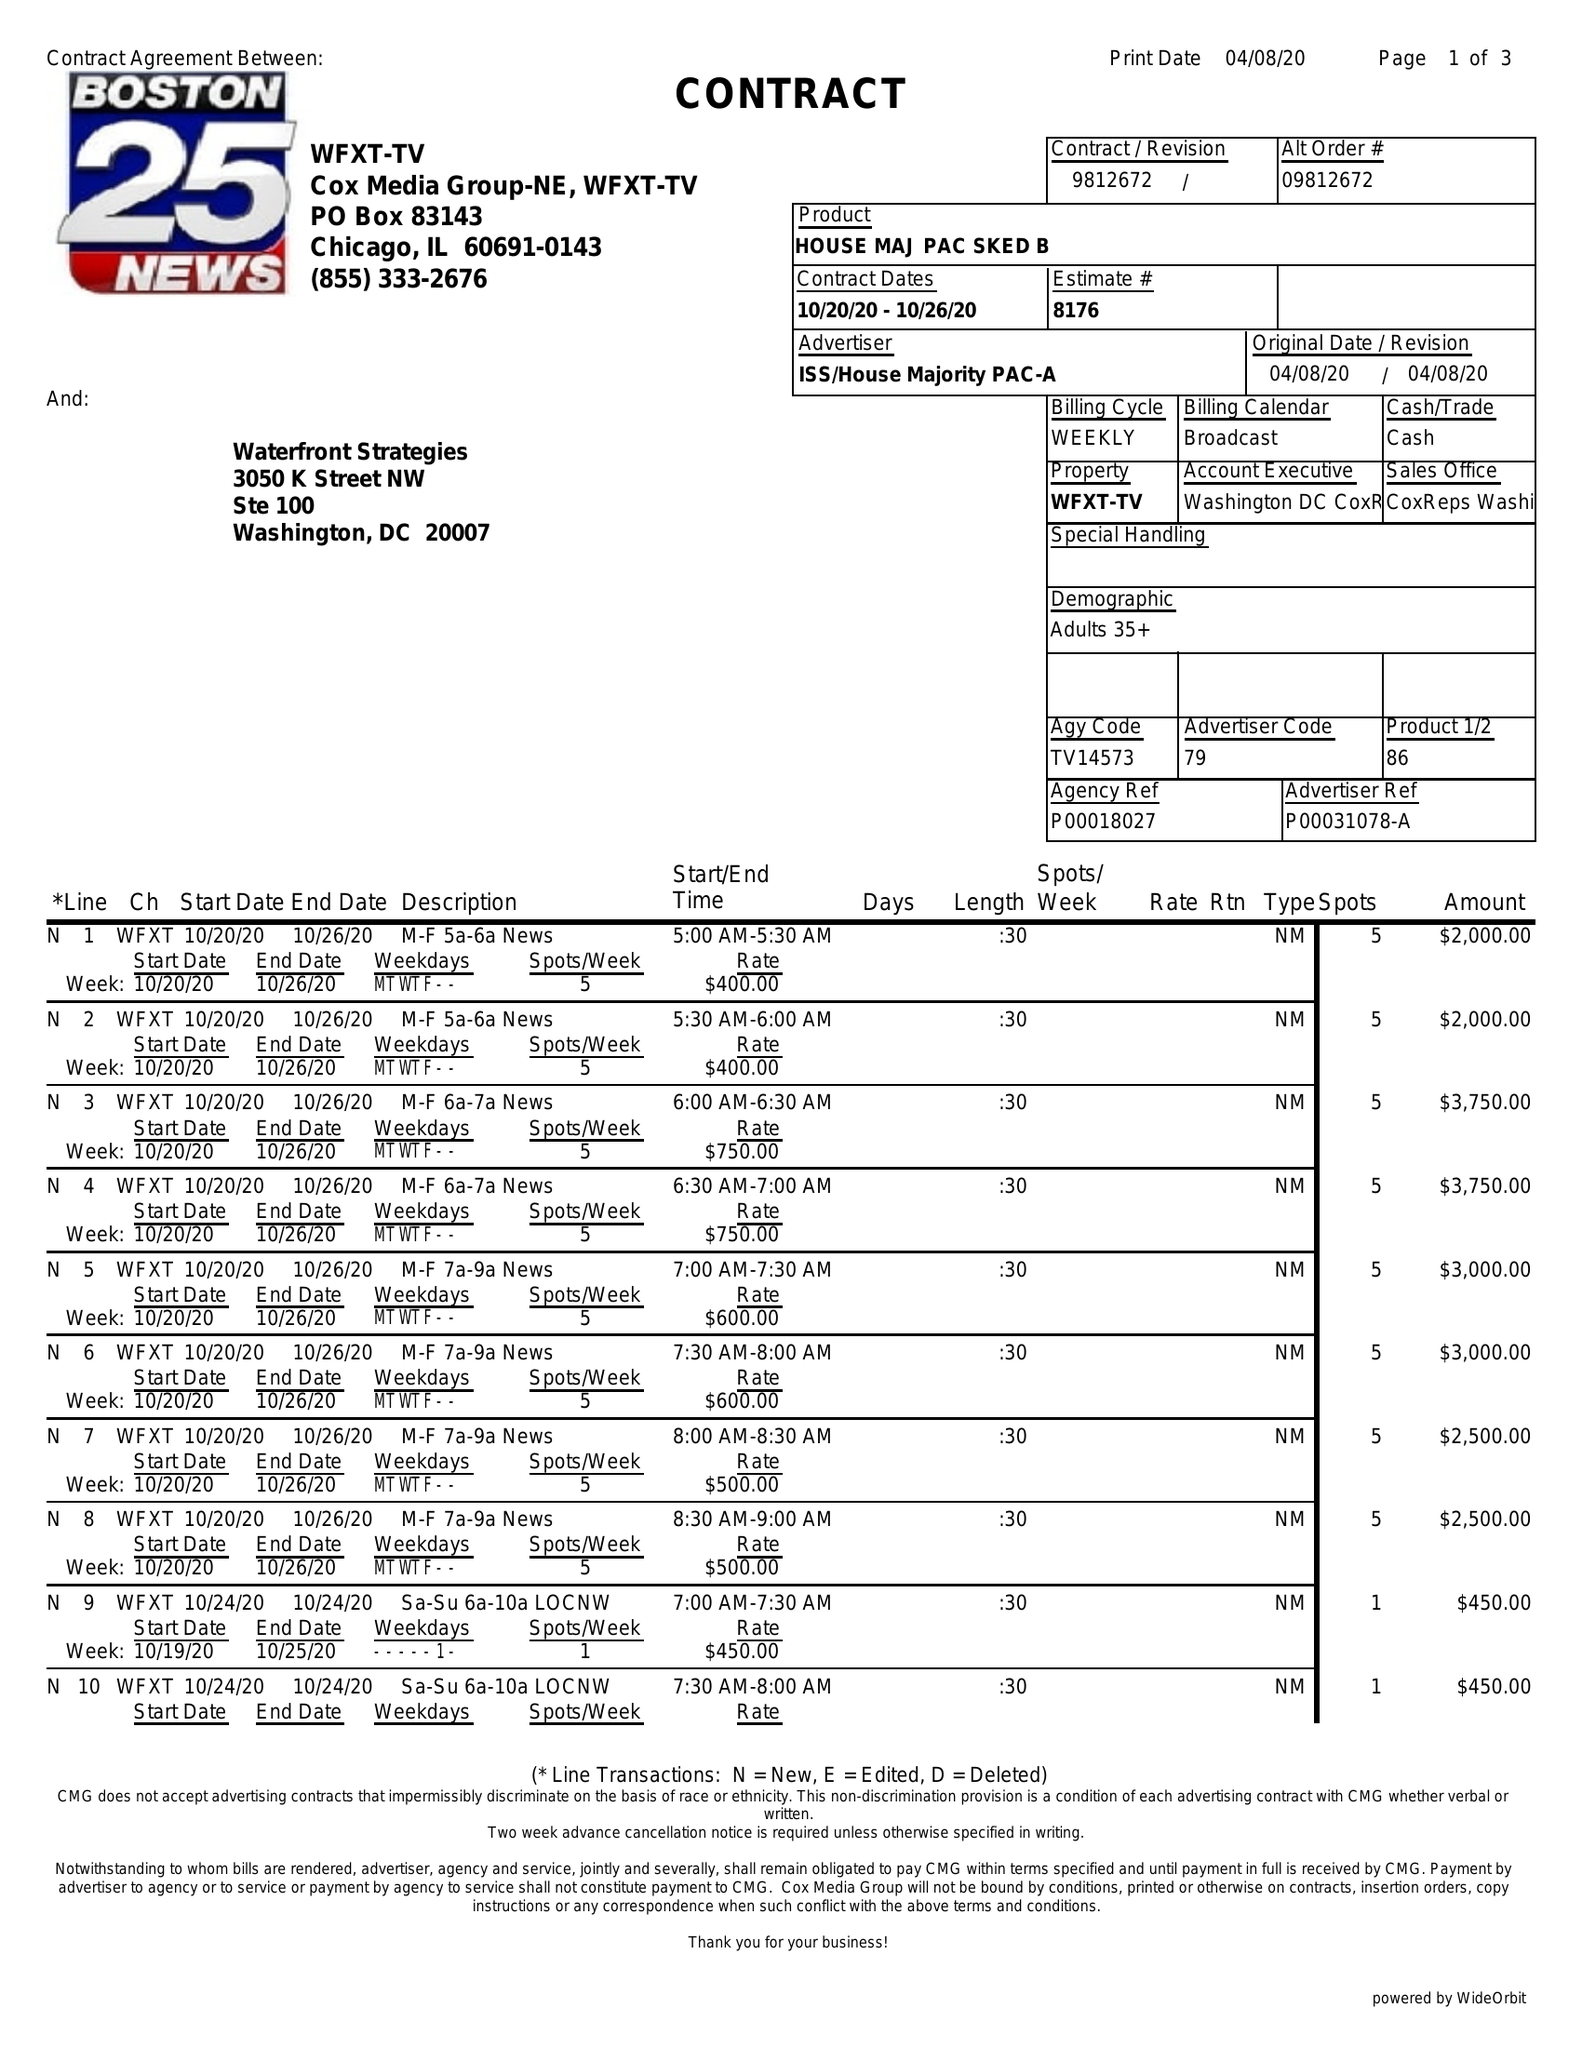What is the value for the flight_from?
Answer the question using a single word or phrase. 10/20/20 